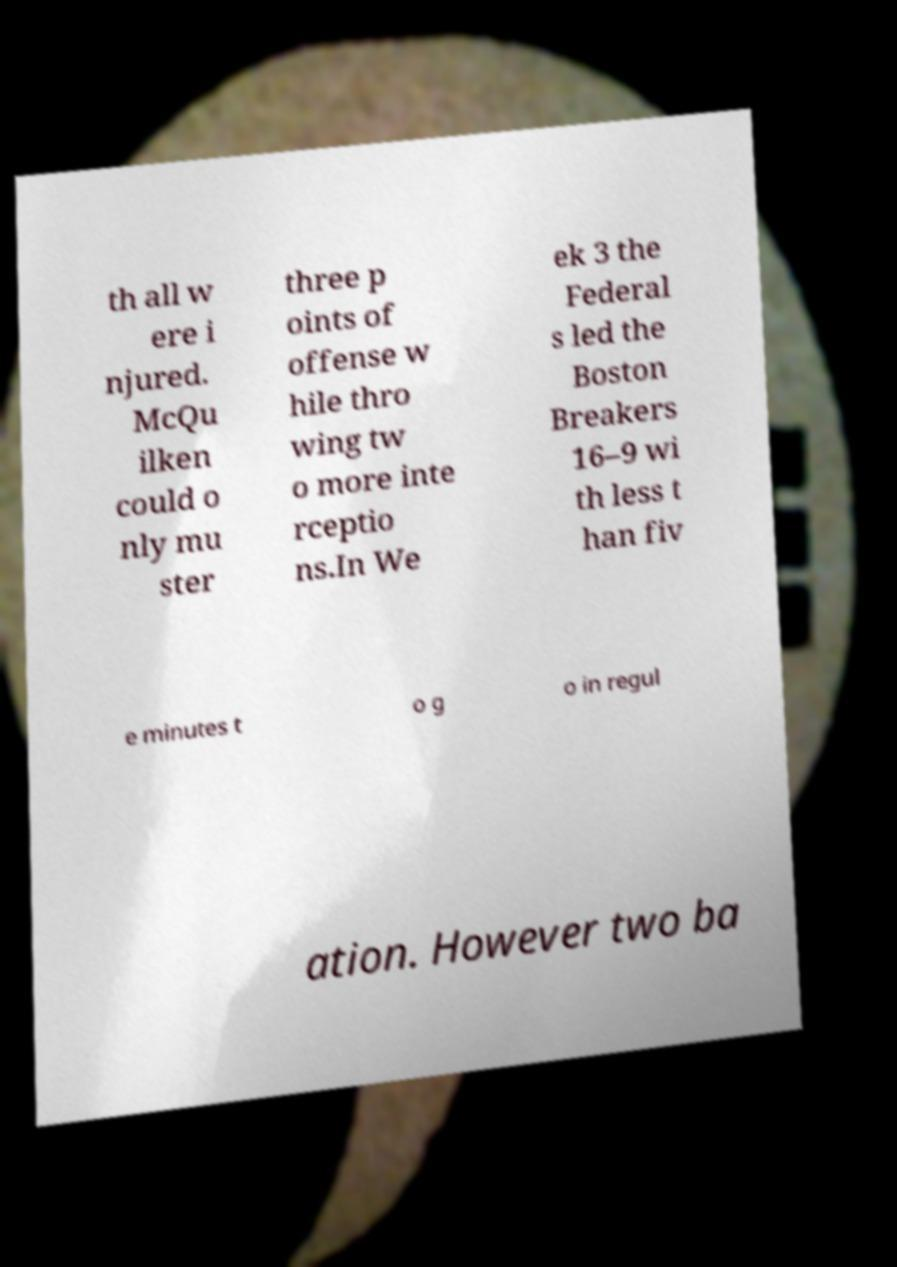For documentation purposes, I need the text within this image transcribed. Could you provide that? th all w ere i njured. McQu ilken could o nly mu ster three p oints of offense w hile thro wing tw o more inte rceptio ns.In We ek 3 the Federal s led the Boston Breakers 16–9 wi th less t han fiv e minutes t o g o in regul ation. However two ba 